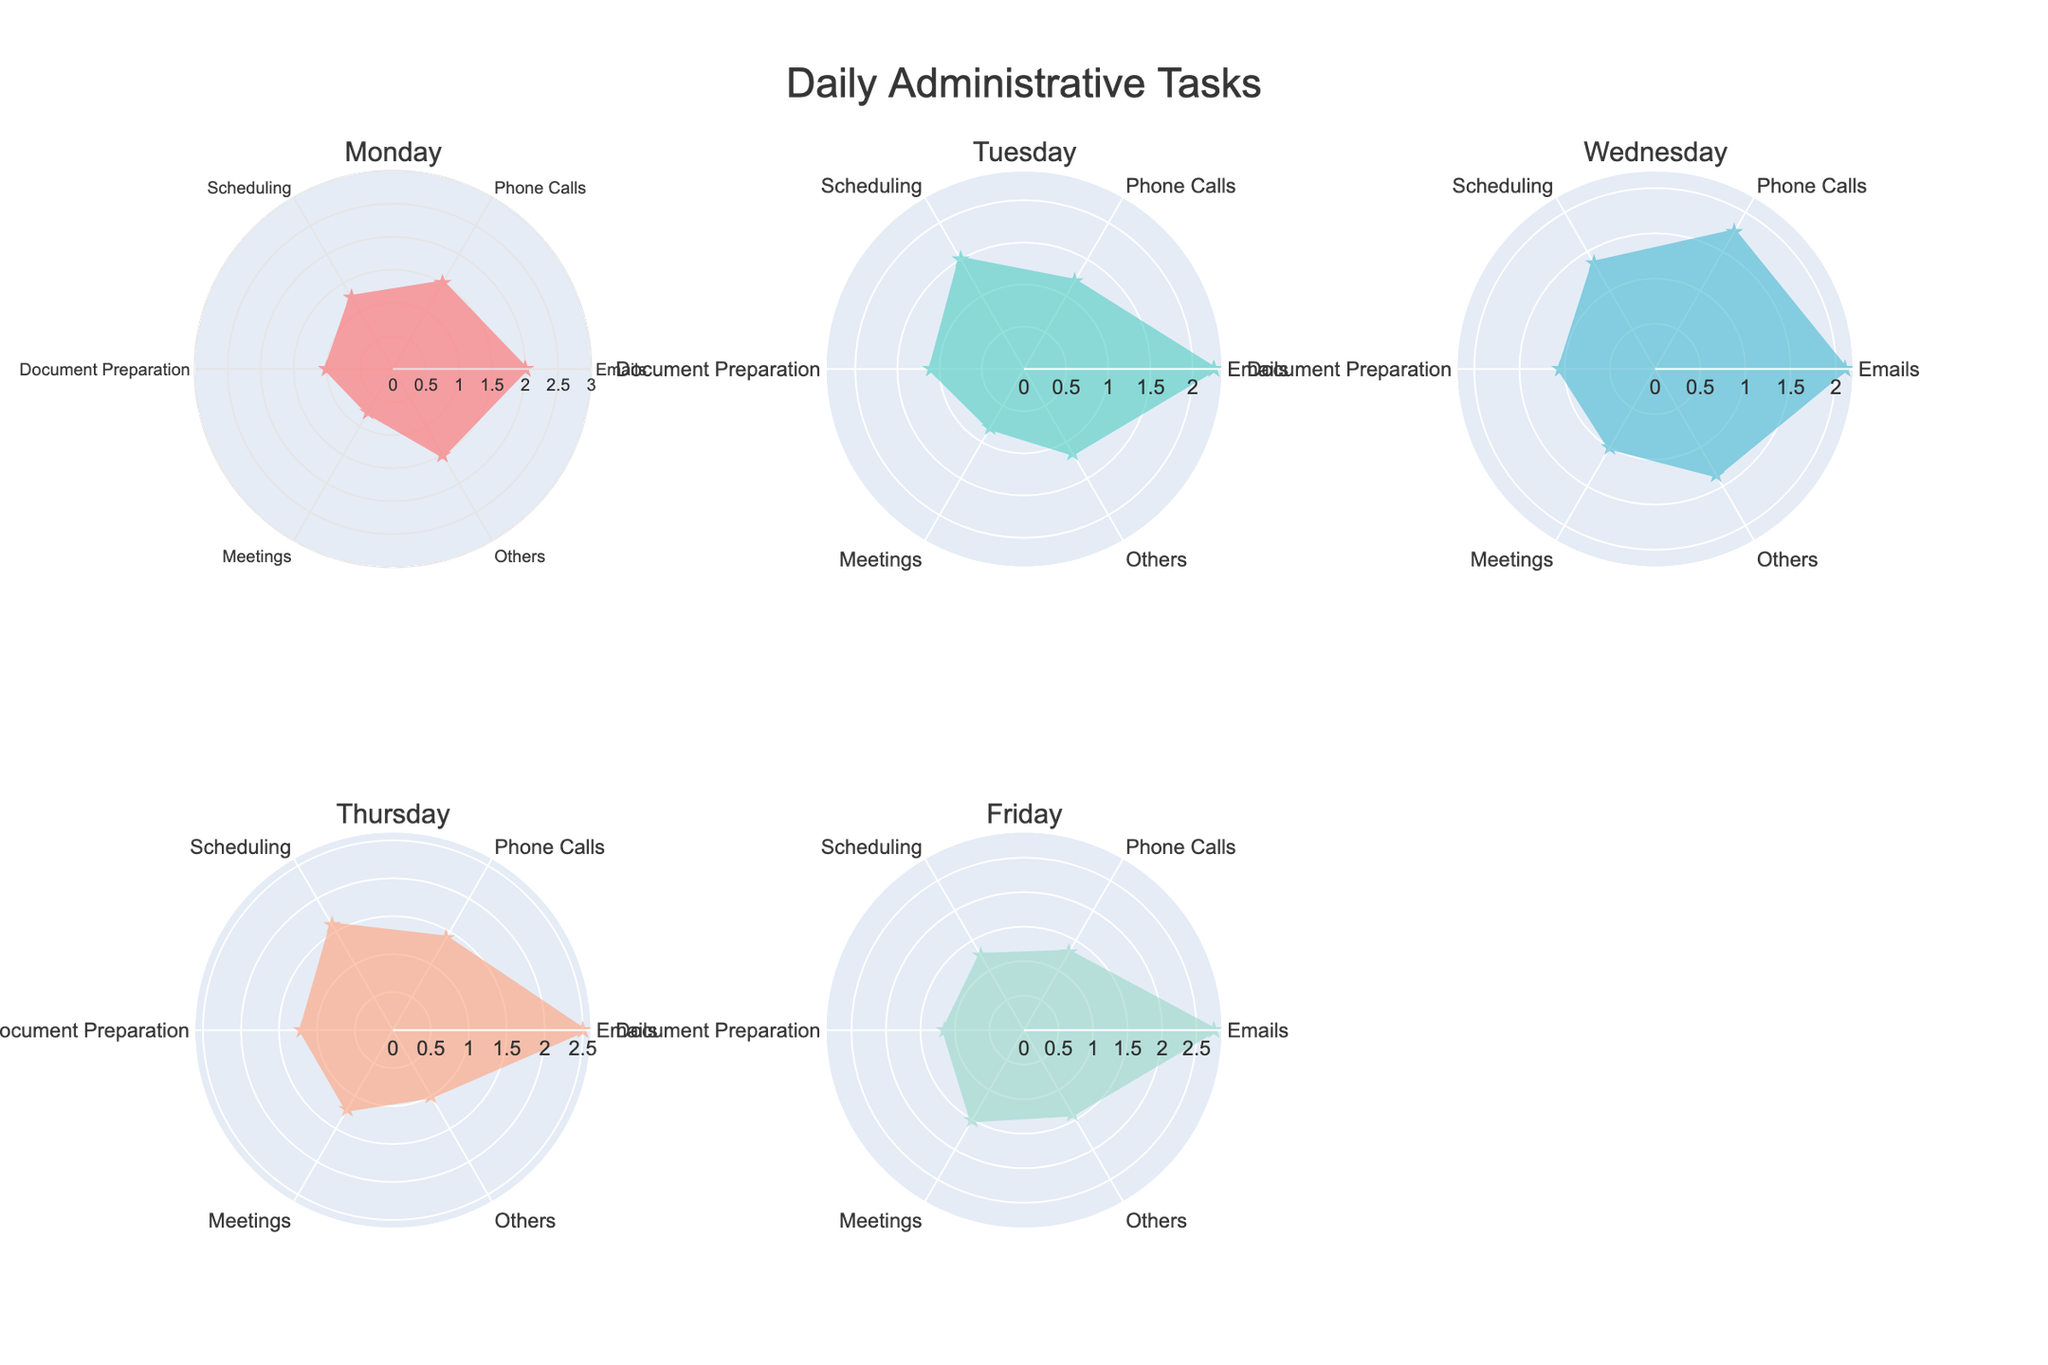How many subplots are there in the figure? Count the total number of subplots in the grid. Since the figure has 2 rows and 3 columns, there are 6 subplots in total
Answer: 6 What is the title of the figure? The title of the figure is written centrally above the subplots. It reads "Daily Administrative Tasks"
Answer: Daily Administrative Tasks On which day is the highest time spent on Emails? To find this, look at the radial value for Emails for each day and identify the highest value. The highest value for Emails is 2.75 on Friday
Answer: Friday What is the total time spent on Scheduling on Monday and Thursday? Add up the time spent on Scheduling on Monday (1.25 hours) with the time spent on Thursday (1.6 hours): 1.25 + 1.6 = 2.85 hours
Answer: 2.85 hours Compare the time spent on Meetings on Friday and Tuesday. Which day has more time spent? Check the radial values for Meetings on both Friday (1.5 hours) and Tuesday (0.8 hours) and compare them. Friday has more time spent on Meetings
Answer: Friday Which day has the least uniformity between tasks? Look for the day with the most varied values on the radar chart. Thursday shows high variation with different times ranging from 1.0 to 2.5 hours across tasks
Answer: Thursday What is the average time spent on Phone Calls over all days? Add up the time for Phone Calls for all days (1.5 + 1.2 + 1.75 + 1.4 + 1.3 = 7.15 hours), then divide by 5 days: 7.15/5 = 1.43 hours
Answer: 1.43 hours Which day has the overall highest cumulative time spent on all tasks? Calculate the sum of time spent on all tasks for each day, and identify the day with the highest total. Friday has the highest total with 9.35 hours (2.75+1.3+1.25+1.15+1.5+1.4)
Answer: Friday What is the most consistent task time-wise across all days? Identify the task that has the smallest variation in the time spent across all days. Emails shows the most consistency with times ranging from 2 to 2.75 hours
Answer: Emails 